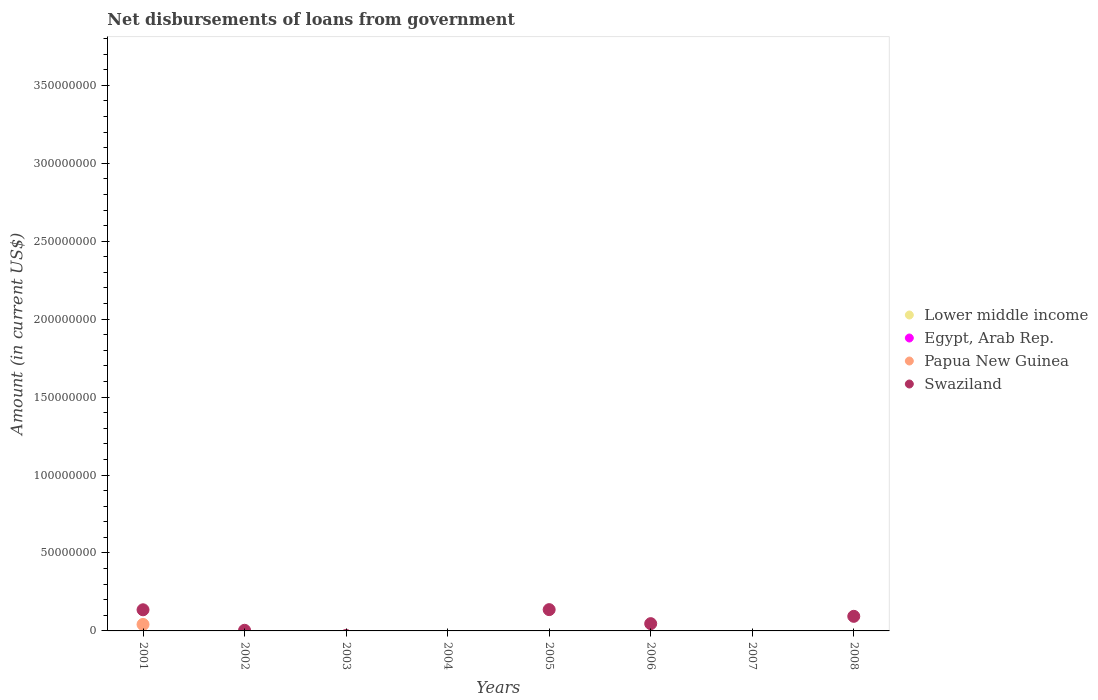Is the number of dotlines equal to the number of legend labels?
Your response must be concise. No. What is the amount of loan disbursed from government in Swaziland in 2007?
Your answer should be very brief. 0. Across all years, what is the maximum amount of loan disbursed from government in Swaziland?
Provide a succinct answer. 1.37e+07. Across all years, what is the minimum amount of loan disbursed from government in Papua New Guinea?
Offer a very short reply. 0. What is the total amount of loan disbursed from government in Papua New Guinea in the graph?
Give a very brief answer. 4.16e+06. What is the average amount of loan disbursed from government in Swaziland per year?
Make the answer very short. 5.21e+06. In the year 2001, what is the difference between the amount of loan disbursed from government in Papua New Guinea and amount of loan disbursed from government in Swaziland?
Offer a terse response. -9.39e+06. What is the ratio of the amount of loan disbursed from government in Swaziland in 2005 to that in 2006?
Your response must be concise. 2.93. Is the amount of loan disbursed from government in Swaziland in 2006 less than that in 2008?
Provide a succinct answer. Yes. What is the difference between the highest and the second highest amount of loan disbursed from government in Swaziland?
Offer a terse response. 1.04e+05. What is the difference between the highest and the lowest amount of loan disbursed from government in Swaziland?
Provide a succinct answer. 1.37e+07. In how many years, is the amount of loan disbursed from government in Swaziland greater than the average amount of loan disbursed from government in Swaziland taken over all years?
Provide a succinct answer. 3. Is it the case that in every year, the sum of the amount of loan disbursed from government in Egypt, Arab Rep. and amount of loan disbursed from government in Papua New Guinea  is greater than the sum of amount of loan disbursed from government in Lower middle income and amount of loan disbursed from government in Swaziland?
Your answer should be very brief. No. Is it the case that in every year, the sum of the amount of loan disbursed from government in Lower middle income and amount of loan disbursed from government in Egypt, Arab Rep.  is greater than the amount of loan disbursed from government in Papua New Guinea?
Offer a very short reply. No. Does the amount of loan disbursed from government in Papua New Guinea monotonically increase over the years?
Your response must be concise. No. Is the amount of loan disbursed from government in Egypt, Arab Rep. strictly greater than the amount of loan disbursed from government in Papua New Guinea over the years?
Provide a succinct answer. No. What is the difference between two consecutive major ticks on the Y-axis?
Your answer should be very brief. 5.00e+07. Does the graph contain any zero values?
Offer a very short reply. Yes. How are the legend labels stacked?
Your answer should be very brief. Vertical. What is the title of the graph?
Keep it short and to the point. Net disbursements of loans from government. What is the Amount (in current US$) of Papua New Guinea in 2001?
Your response must be concise. 4.16e+06. What is the Amount (in current US$) in Swaziland in 2001?
Your response must be concise. 1.36e+07. What is the Amount (in current US$) in Lower middle income in 2002?
Provide a succinct answer. 0. What is the Amount (in current US$) of Egypt, Arab Rep. in 2002?
Your response must be concise. 0. What is the Amount (in current US$) in Swaziland in 2002?
Your response must be concise. 4.11e+05. What is the Amount (in current US$) in Egypt, Arab Rep. in 2003?
Keep it short and to the point. 0. What is the Amount (in current US$) of Lower middle income in 2004?
Make the answer very short. 0. What is the Amount (in current US$) in Lower middle income in 2005?
Give a very brief answer. 0. What is the Amount (in current US$) of Papua New Guinea in 2005?
Provide a short and direct response. 0. What is the Amount (in current US$) of Swaziland in 2005?
Keep it short and to the point. 1.37e+07. What is the Amount (in current US$) in Lower middle income in 2006?
Keep it short and to the point. 0. What is the Amount (in current US$) in Swaziland in 2006?
Your answer should be very brief. 4.66e+06. What is the Amount (in current US$) in Egypt, Arab Rep. in 2007?
Offer a terse response. 0. What is the Amount (in current US$) of Lower middle income in 2008?
Make the answer very short. 0. What is the Amount (in current US$) in Egypt, Arab Rep. in 2008?
Provide a succinct answer. 0. What is the Amount (in current US$) in Swaziland in 2008?
Your response must be concise. 9.36e+06. Across all years, what is the maximum Amount (in current US$) in Papua New Guinea?
Your answer should be very brief. 4.16e+06. Across all years, what is the maximum Amount (in current US$) in Swaziland?
Provide a short and direct response. 1.37e+07. Across all years, what is the minimum Amount (in current US$) of Papua New Guinea?
Your response must be concise. 0. Across all years, what is the minimum Amount (in current US$) of Swaziland?
Keep it short and to the point. 0. What is the total Amount (in current US$) in Egypt, Arab Rep. in the graph?
Provide a succinct answer. 0. What is the total Amount (in current US$) in Papua New Guinea in the graph?
Offer a very short reply. 4.16e+06. What is the total Amount (in current US$) in Swaziland in the graph?
Give a very brief answer. 4.17e+07. What is the difference between the Amount (in current US$) of Swaziland in 2001 and that in 2002?
Ensure brevity in your answer.  1.31e+07. What is the difference between the Amount (in current US$) in Swaziland in 2001 and that in 2005?
Ensure brevity in your answer.  -1.04e+05. What is the difference between the Amount (in current US$) of Swaziland in 2001 and that in 2006?
Make the answer very short. 8.89e+06. What is the difference between the Amount (in current US$) in Swaziland in 2001 and that in 2008?
Ensure brevity in your answer.  4.19e+06. What is the difference between the Amount (in current US$) of Swaziland in 2002 and that in 2005?
Offer a terse response. -1.32e+07. What is the difference between the Amount (in current US$) of Swaziland in 2002 and that in 2006?
Your answer should be compact. -4.25e+06. What is the difference between the Amount (in current US$) in Swaziland in 2002 and that in 2008?
Provide a succinct answer. -8.95e+06. What is the difference between the Amount (in current US$) in Swaziland in 2005 and that in 2006?
Offer a very short reply. 9.00e+06. What is the difference between the Amount (in current US$) in Swaziland in 2005 and that in 2008?
Your answer should be compact. 4.30e+06. What is the difference between the Amount (in current US$) in Swaziland in 2006 and that in 2008?
Offer a very short reply. -4.70e+06. What is the difference between the Amount (in current US$) in Papua New Guinea in 2001 and the Amount (in current US$) in Swaziland in 2002?
Offer a very short reply. 3.75e+06. What is the difference between the Amount (in current US$) in Papua New Guinea in 2001 and the Amount (in current US$) in Swaziland in 2005?
Keep it short and to the point. -9.50e+06. What is the difference between the Amount (in current US$) in Papua New Guinea in 2001 and the Amount (in current US$) in Swaziland in 2006?
Make the answer very short. -5.01e+05. What is the difference between the Amount (in current US$) of Papua New Guinea in 2001 and the Amount (in current US$) of Swaziland in 2008?
Your response must be concise. -5.20e+06. What is the average Amount (in current US$) in Lower middle income per year?
Ensure brevity in your answer.  0. What is the average Amount (in current US$) of Papua New Guinea per year?
Keep it short and to the point. 5.20e+05. What is the average Amount (in current US$) in Swaziland per year?
Give a very brief answer. 5.21e+06. In the year 2001, what is the difference between the Amount (in current US$) of Papua New Guinea and Amount (in current US$) of Swaziland?
Your response must be concise. -9.39e+06. What is the ratio of the Amount (in current US$) in Swaziland in 2001 to that in 2002?
Provide a short and direct response. 32.98. What is the ratio of the Amount (in current US$) in Swaziland in 2001 to that in 2006?
Your response must be concise. 2.91. What is the ratio of the Amount (in current US$) in Swaziland in 2001 to that in 2008?
Provide a short and direct response. 1.45. What is the ratio of the Amount (in current US$) in Swaziland in 2002 to that in 2005?
Keep it short and to the point. 0.03. What is the ratio of the Amount (in current US$) of Swaziland in 2002 to that in 2006?
Your answer should be compact. 0.09. What is the ratio of the Amount (in current US$) of Swaziland in 2002 to that in 2008?
Ensure brevity in your answer.  0.04. What is the ratio of the Amount (in current US$) of Swaziland in 2005 to that in 2006?
Offer a terse response. 2.93. What is the ratio of the Amount (in current US$) in Swaziland in 2005 to that in 2008?
Make the answer very short. 1.46. What is the ratio of the Amount (in current US$) of Swaziland in 2006 to that in 2008?
Give a very brief answer. 0.5. What is the difference between the highest and the second highest Amount (in current US$) in Swaziland?
Your answer should be compact. 1.04e+05. What is the difference between the highest and the lowest Amount (in current US$) of Papua New Guinea?
Offer a terse response. 4.16e+06. What is the difference between the highest and the lowest Amount (in current US$) in Swaziland?
Offer a very short reply. 1.37e+07. 